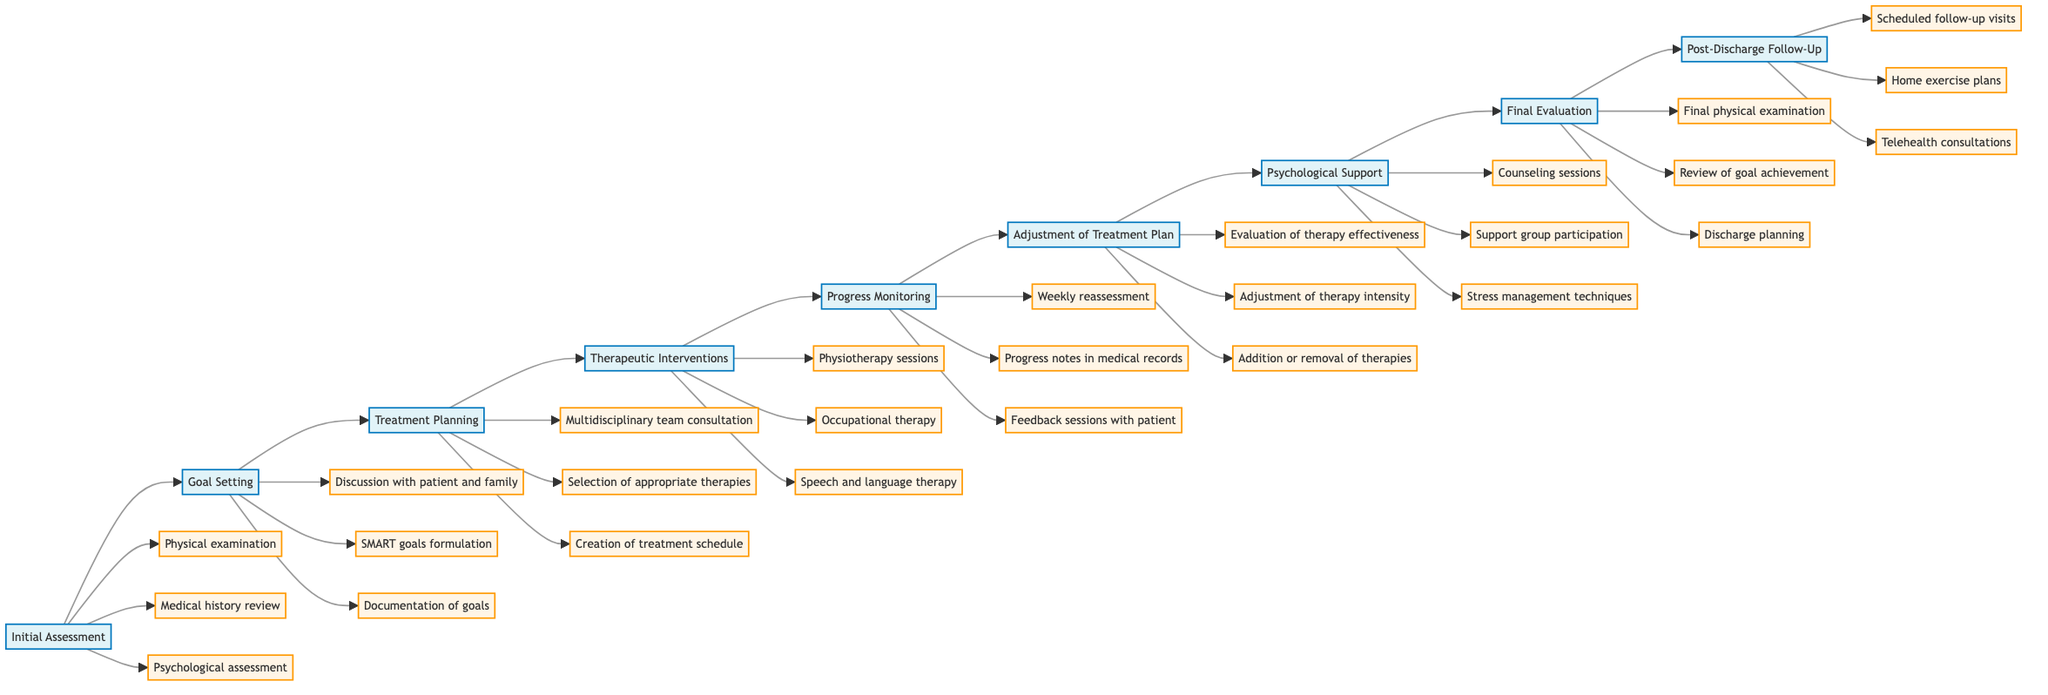What is the first step in the timeline? The first step in the timeline is indicated as "Initial Assessment," which the arrows point to as the starting point of the flowchart.
Answer: Initial Assessment How many main steps are in the flowchart? The flowchart contains a total of 9 main steps as seen from the labels in the diagram.
Answer: 9 Which step follows "Progress Monitoring"? By following the directional arrows in the flowchart, it is clear that "Adjustment of Treatment Plan" comes immediately after "Progress Monitoring".
Answer: Adjustment of Treatment Plan What activities are associated with the "Psychological Support" step? The activities listed under the "Psychological Support" step are present in the diagram as branches connected to it, indicating the specific actions taken during this step.
Answer: Counseling sessions, Support group participation, Stress management techniques What is the last step in the timeline? The last step is shown at the end of the flowchart and follows directly from "Final Evaluation", confirming the end of the rehabilitation timeline.
Answer: Post-Discharge Follow-Up Which step is directly connected to "Goal Setting"? Tracking the flow from "Goal Setting" shows that the connection leads directly to "Treatment Planning" next in the sequence.
Answer: Treatment Planning What is the main purpose of the "Initial Assessment" step? The description in the diagram for "Initial Assessment" indicates that it serves the purpose of a comprehensive evaluation of the patient's physical and psychological condition.
Answer: Comprehensive evaluation of patient's physical and psychological condition Which therapy is included in "Therapeutic Interventions"? Examining the activities listed under "Therapeutic Interventions" reveals that "Occupational therapy" is one of the modalities included.
Answer: Occupational therapy How is the effectiveness of therapy evaluated according to the flowchart? The "Evaluation of therapy effectiveness" mentioned under "Adjustment of Treatment Plan" indicates how the effectiveness of the therapy is assessed in the rehabilitation process.
Answer: Evaluation of therapy effectiveness 